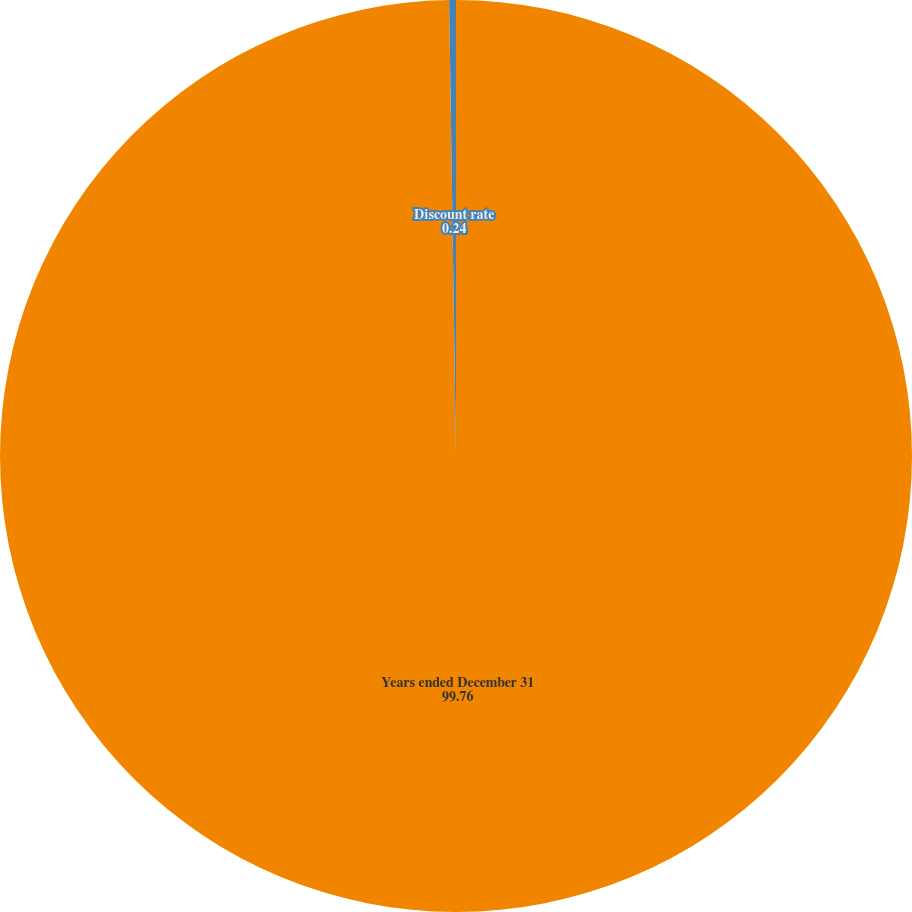<chart> <loc_0><loc_0><loc_500><loc_500><pie_chart><fcel>Years ended December 31<fcel>Discount rate<nl><fcel>99.76%<fcel>0.24%<nl></chart> 